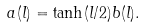<formula> <loc_0><loc_0><loc_500><loc_500>a ( l ) = \tanh ( l / 2 ) b ( l ) .</formula> 